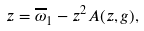<formula> <loc_0><loc_0><loc_500><loc_500>z = \overline { \omega } _ { 1 } - z ^ { 2 } A ( z , g ) ,</formula> 